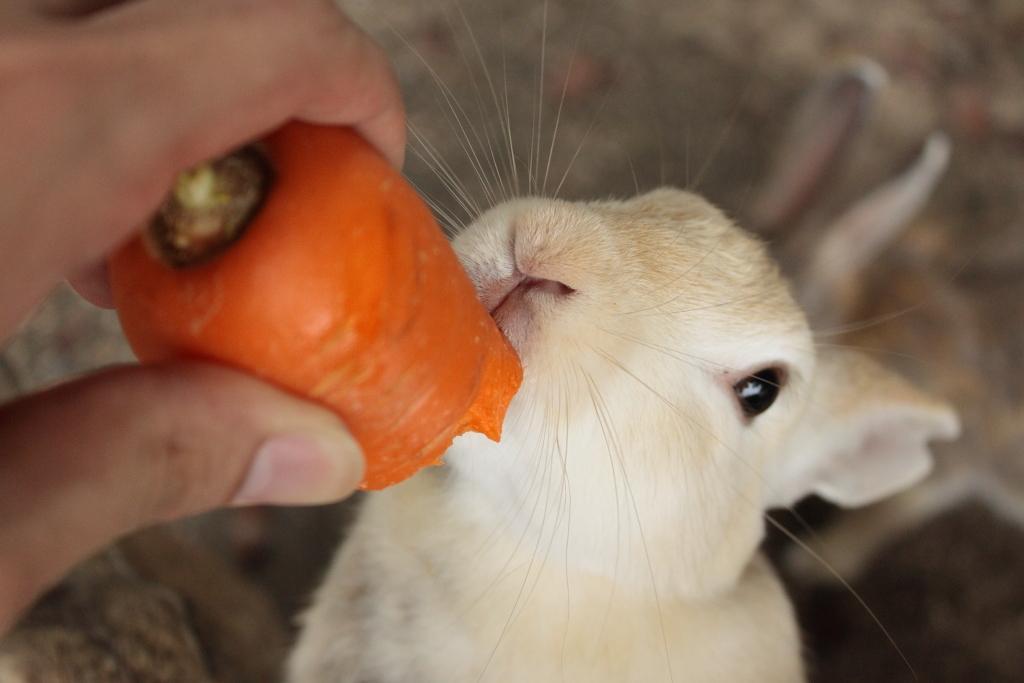How would you summarize this image in a sentence or two? In this image I can see one person is holding the carrot. To the side I can see the rabbit which is in white and cream color. And there is a blurred background. 